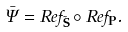Convert formula to latex. <formula><loc_0><loc_0><loc_500><loc_500>\bar { \Psi } = R e f _ { \tilde { \mathbf S } } \circ R e f _ { \mathbf P } .</formula> 